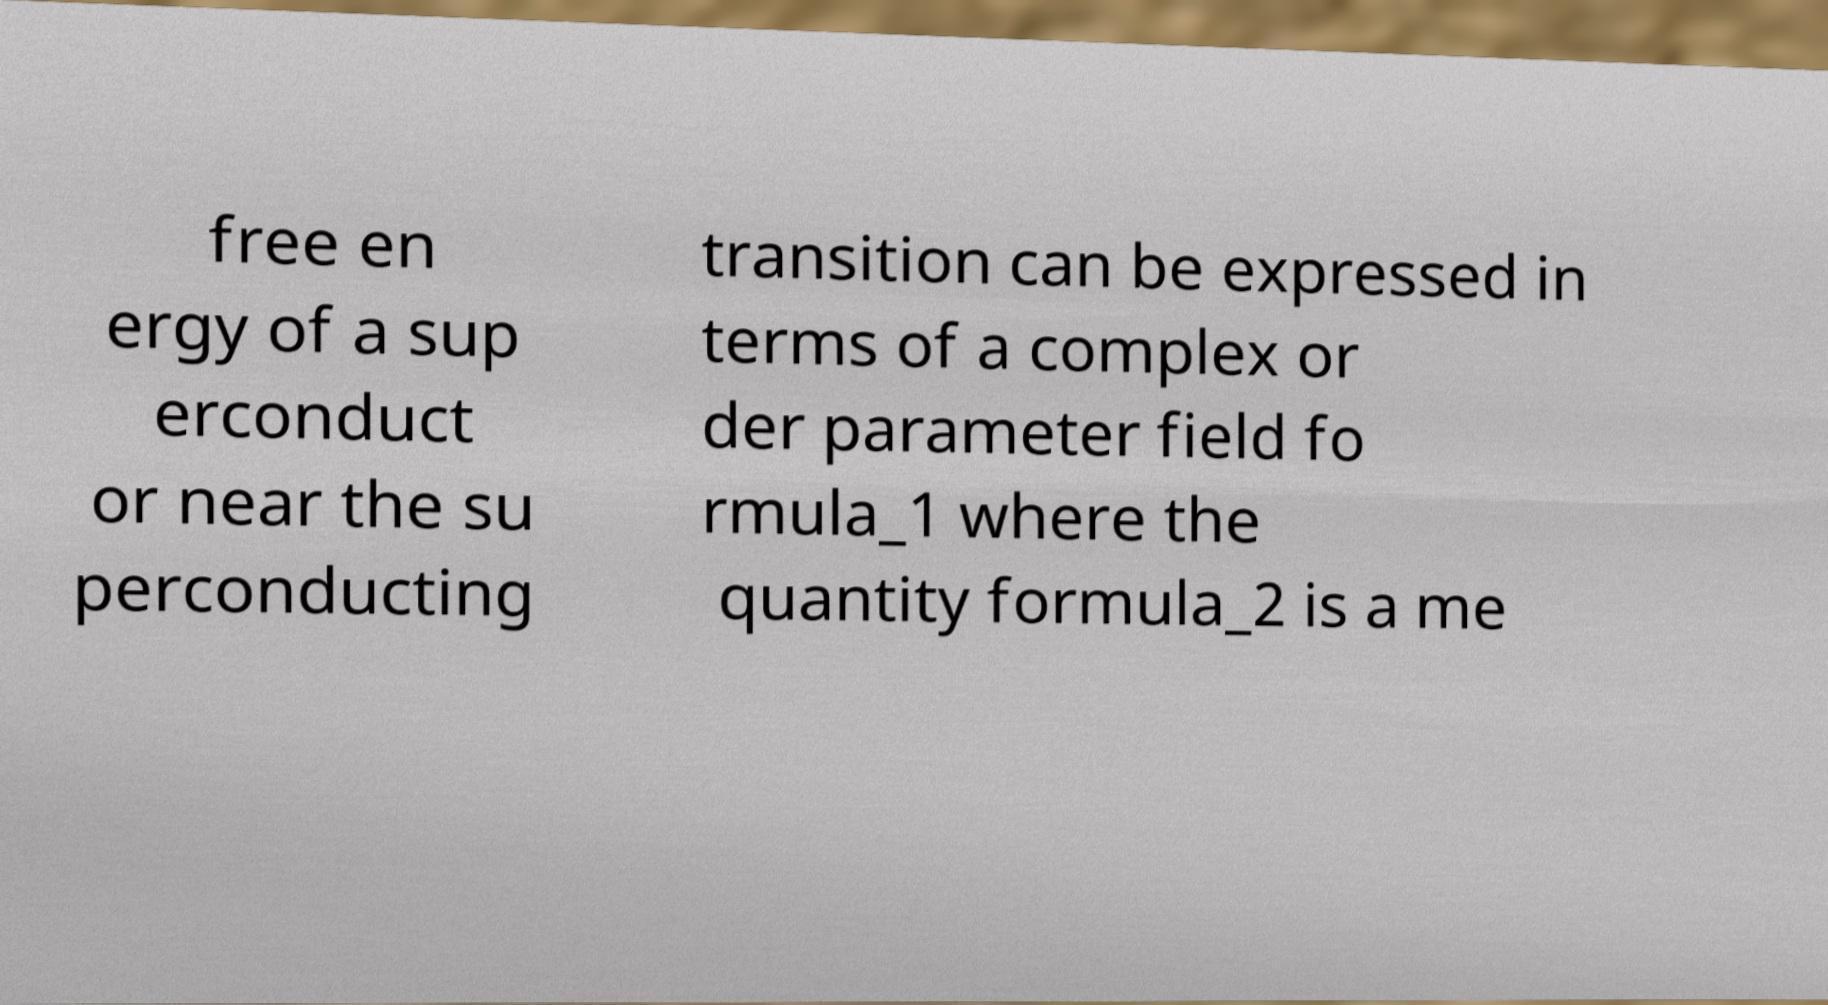Can you read and provide the text displayed in the image?This photo seems to have some interesting text. Can you extract and type it out for me? free en ergy of a sup erconduct or near the su perconducting transition can be expressed in terms of a complex or der parameter field fo rmula_1 where the quantity formula_2 is a me 